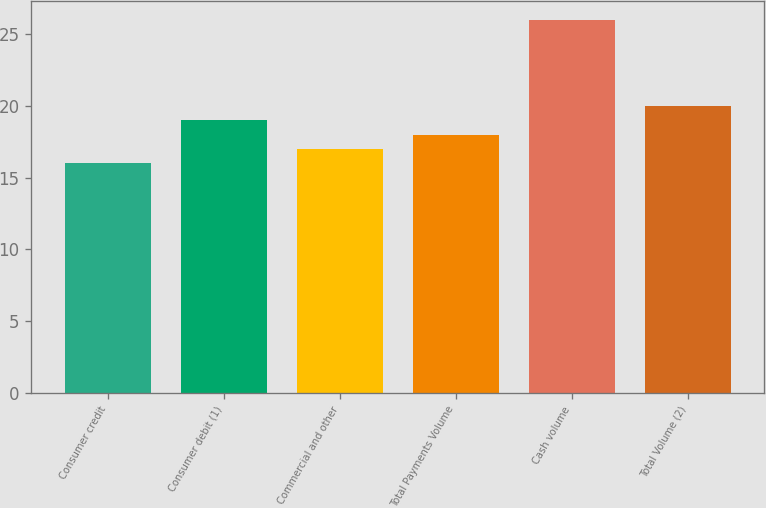<chart> <loc_0><loc_0><loc_500><loc_500><bar_chart><fcel>Consumer credit<fcel>Consumer debit (1)<fcel>Commercial and other<fcel>Total Payments Volume<fcel>Cash volume<fcel>Total Volume (2)<nl><fcel>16<fcel>19<fcel>17<fcel>18<fcel>26<fcel>20<nl></chart> 